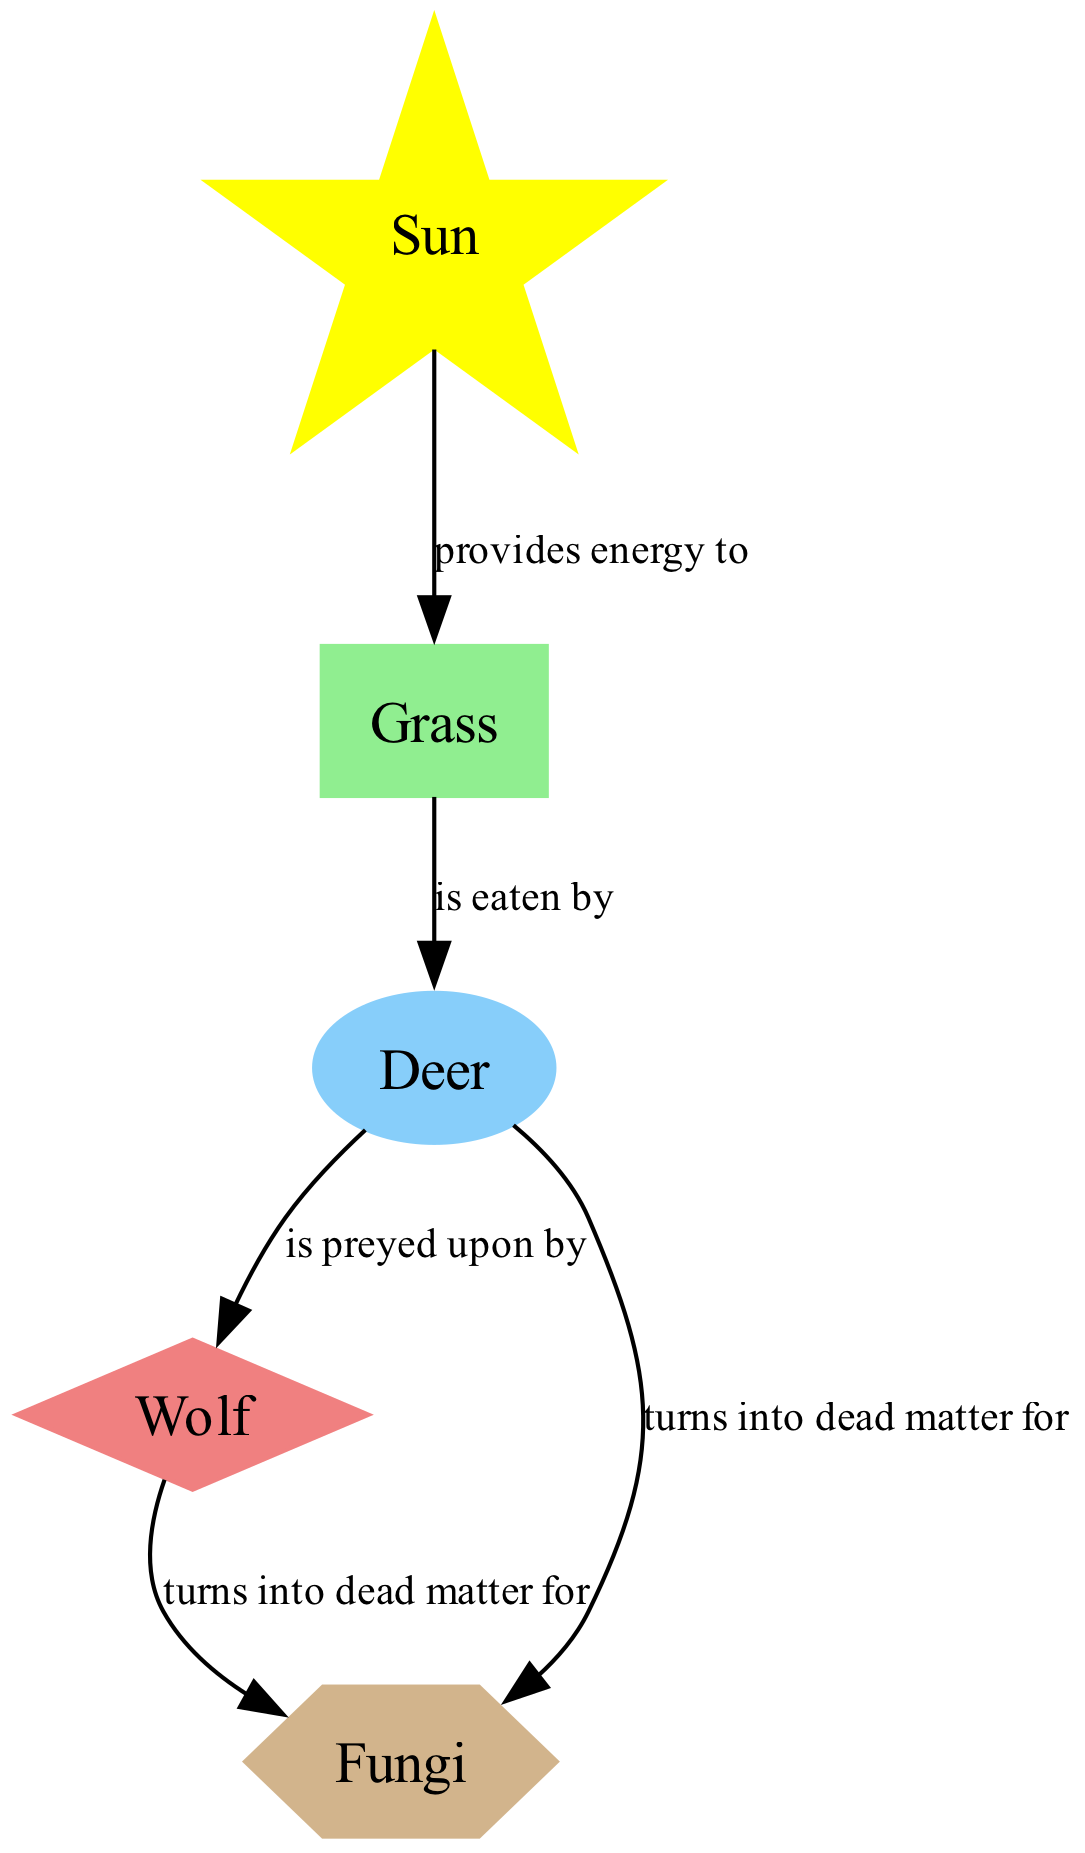What is the total number of nodes in the diagram? The diagram includes five different nodes: Sun, Grass, Deer, Wolf, and Fungi. By counting each distinct label that represents an element in the food web, we find that there are five nodes total.
Answer: 5 Which node is classified as a secondary consumer? From the list of nodes, the Wolf is identified as a secondary consumer. It can be found in the diagram specifically labeled as such, indicating its role in the food web.
Answer: Wolf What type of energy transfer occurs from the sun to grass? The diagram shows that the Sun provides energy to the Grass. This relationship is clearly stated in the diagram’s labeling of the connection between these two nodes, indicating the energy transfer direction.
Answer: provides energy to How many edges are present in the diagram? By examining the connections (edges) between the nodes, we can count a total of four edges: Sun to Grass, Grass to Deer, Deer to Wolf, and two edges from Wolf and Deer to Fungi. Summing these gives us four edges total.
Answer: 5 What are the primary consumers in the ecosystem depicted? The diagram clearly indicates that the Deer is the only node classified as a primary consumer. This classification is shown in the type designation for the Deer in the diagram.
Answer: Deer Which organism turns into dead matter for fungi? The diagram shows two organisms—Wolf and Deer—that turn into dead matter for Fungi. The connections labeled indicate both instances, signifying their importance as sources of matter for the decomposer.
Answer: Wolf, Deer What type of node is 'grass' identified as? In the diagram's classification, Grass is labeled as a producer. The node types clearly differentiate the roles of the various organisms in the ecosystem, confirming Grass as a producer.
Answer: producer How does energy transfer from deer to wolf? The energy transfer occurs through the relationship where the Deer is preyed upon by the Wolf. Hence, the connection in the diagram explicitly shows the direction and nature of energy flow between these two nodes.
Answer: is preyed upon by What is the role of fungi in this food web? Fungi are identified as decomposers within the food web structure. Their role is crucial for breaking down dead matter, which is illustrated in the diagram by their connections to both the Wolf and Deer.
Answer: decomposer 